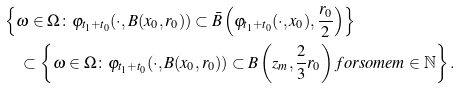Convert formula to latex. <formula><loc_0><loc_0><loc_500><loc_500>& \left \{ \omega \in \Omega \colon \varphi _ { t _ { 1 } + t _ { 0 } } ( \cdot , B ( x _ { 0 } , r _ { 0 } ) ) \subset \bar { B } \left ( \varphi _ { t _ { 1 } + t _ { 0 } } ( \cdot , x _ { 0 } ) , \frac { r _ { 0 } } { 2 } \right ) \right \} \\ & \quad \subset \left \{ \omega \in \Omega \colon \varphi _ { t _ { 1 } + t _ { 0 } } ( \cdot , B ( x _ { 0 } , r _ { 0 } ) ) \subset B \left ( z _ { m } , \frac { 2 } { 3 } r _ { 0 } \right ) f o r s o m e m \in \mathbb { N } \right \} .</formula> 